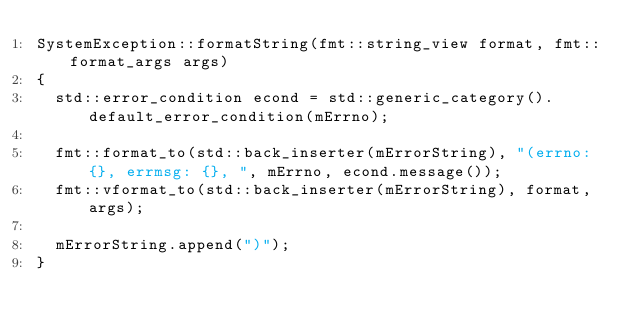Convert code to text. <code><loc_0><loc_0><loc_500><loc_500><_C++_>SystemException::formatString(fmt::string_view format, fmt::format_args args)
{
	std::error_condition econd = std::generic_category().default_error_condition(mErrno);

	fmt::format_to(std::back_inserter(mErrorString), "(errno: {}, errmsg: {}, ", mErrno, econd.message());
	fmt::vformat_to(std::back_inserter(mErrorString), format, args);
        
	mErrorString.append(")");
}
</code> 